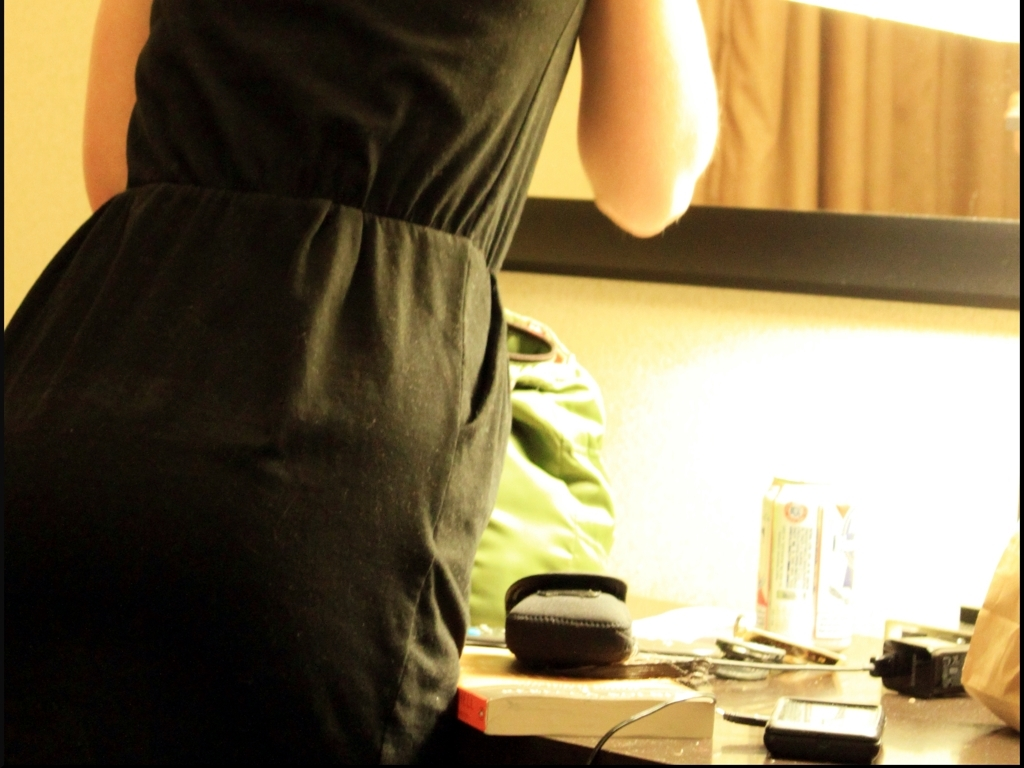Can you describe the objects on the table? The table contains a collection of everyday items including a wallet, a pair of headphones, keys, a phone, and a beverage can. The array of personal items suggests this could be a snapshot of someone's daily life, capturing the end of a long day or perhaps a moment of pause. 